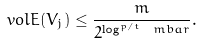Convert formula to latex. <formula><loc_0><loc_0><loc_500><loc_500>\ v o l { E ( V _ { j } ) } \leq \frac { m } { 2 ^ { \log ^ { p / t } \ m b a r } } .</formula> 